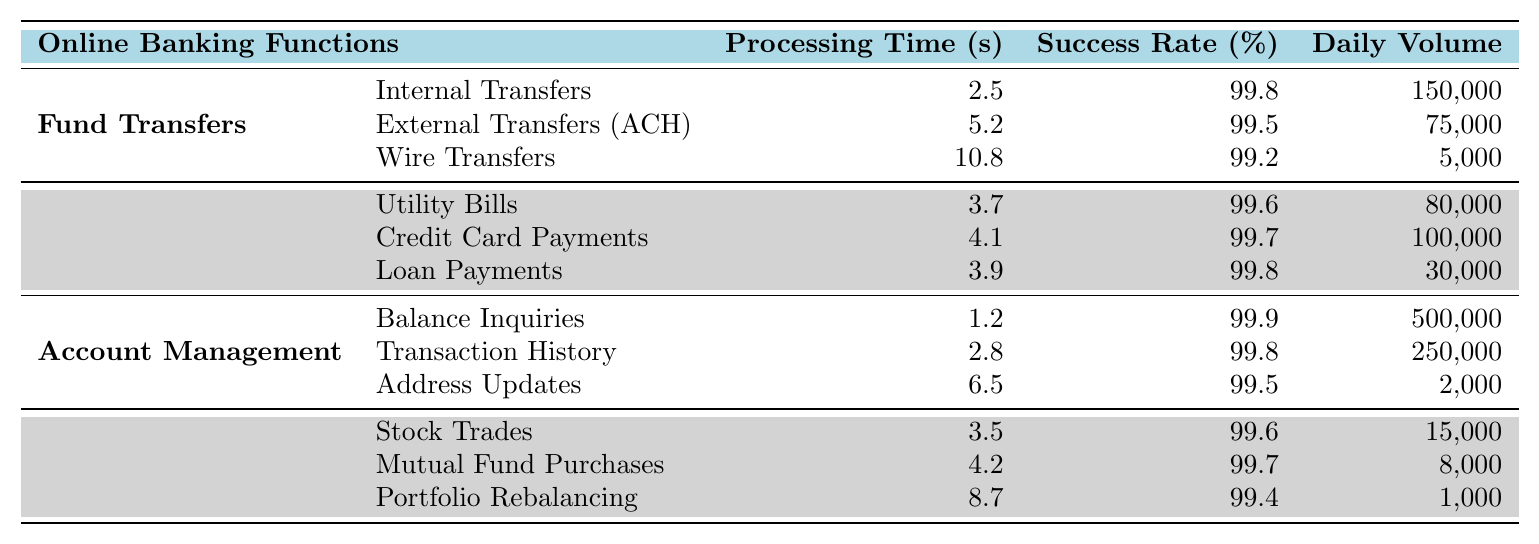What is the processing time for Internal Transfers? The processing time for Internal Transfers is listed directly in the table under Fund Transfers. The value recorded is 2.5 seconds.
Answer: 2.5 seconds What is the success rate for External Transfers (ACH)? The success rate for External Transfers (ACH) can be found in the table and is recorded as 99.5%.
Answer: 99.5% How many daily transactions are there for Balance Inquiries? The daily volume for Balance Inquiries is specified under Account Management in the table, with a value of 500,000.
Answer: 500,000 Which online banking function has the highest processing time? To find the highest processing time, compare all processing times listed in the table. Wire Transfers have the highest at 10.8 seconds.
Answer: Wire Transfers What is the overall average processing time for all online banking functions? To calculate the average processing time, sum all the individual processing times: (2.5 + 5.2 + 10.8 + 3.7 + 4.1 + 3.9 + 1.2 + 2.8 + 6.5 + 3.5 + 4.2 + 8.7) = 54.4 seconds. There are 12 functions, so divide by 12: 54.4/12 = 4.53 seconds.
Answer: 4.53 seconds Do Utility Bills have a higher success rate than Credit Card Payments? The success rates for both can be found in the table: Utility Bills have a success rate of 99.6% while Credit Card Payments have 99.7%. Therefore, no, Utility Bills do not have a higher success rate.
Answer: No What is the total daily volume for Investment Services? The daily volumes for Investment Services (Stock Trades: 15,000, Mutual Fund Purchases: 8,000, Portfolio Rebalancing: 1,000) should be summed: 15,000 + 8,000 + 1,000 = 24,000.
Answer: 24,000 Is the success rate for Loan Payments higher than for Wire Transfers? From the table, Loan Payments have a success rate of 99.8% and Wire Transfers have a success rate of 99.2%. Thus, yes, Loan Payments have a higher success rate.
Answer: Yes What function has the least daily volume, and what is that volume? By examining the daily volume for each function, Address Updates has the least volume at 2,000 transactions.
Answer: Address Updates, 2,000 How much quicker, in seconds, is Balance Inquiries compared to Wire Transfers? The processing time for Balance Inquiries is 1.2 seconds and for Wire Transfers is 10.8 seconds. The difference is 10.8 - 1.2 = 9.6 seconds, indicating that Balance Inquiries are quicker.
Answer: 9.6 seconds 